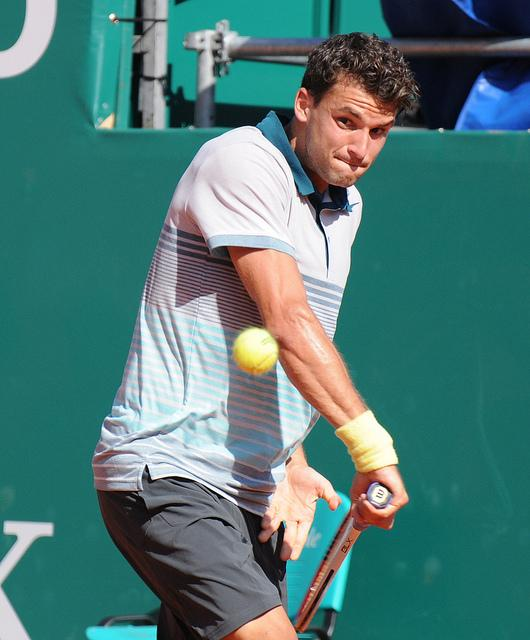What manner will the person here hit the ball? backhand 